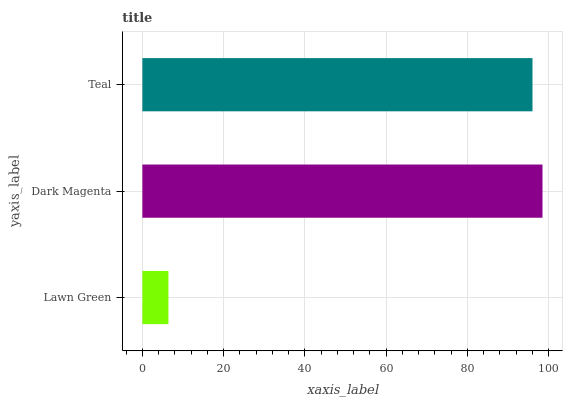Is Lawn Green the minimum?
Answer yes or no. Yes. Is Dark Magenta the maximum?
Answer yes or no. Yes. Is Teal the minimum?
Answer yes or no. No. Is Teal the maximum?
Answer yes or no. No. Is Dark Magenta greater than Teal?
Answer yes or no. Yes. Is Teal less than Dark Magenta?
Answer yes or no. Yes. Is Teal greater than Dark Magenta?
Answer yes or no. No. Is Dark Magenta less than Teal?
Answer yes or no. No. Is Teal the high median?
Answer yes or no. Yes. Is Teal the low median?
Answer yes or no. Yes. Is Dark Magenta the high median?
Answer yes or no. No. Is Dark Magenta the low median?
Answer yes or no. No. 